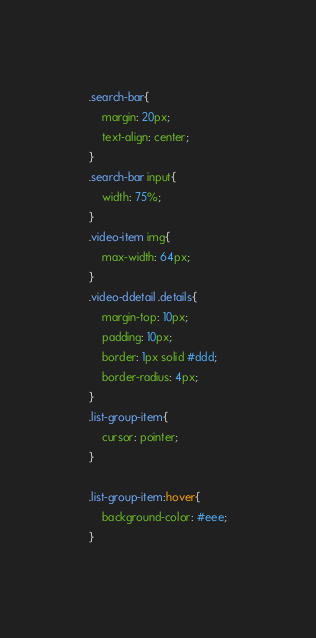<code> <loc_0><loc_0><loc_500><loc_500><_CSS_>.search-bar{
    margin: 20px;
    text-align: center;
}
.search-bar input{
    width: 75%;
}
.video-item img{
    max-width: 64px;
}
.video-ddetail .details{
    margin-top: 10px;
    padding: 10px;
    border: 1px solid #ddd;
    border-radius: 4px;
}
.list-group-item{
    cursor: pointer;
}

.list-group-item:hover{
    background-color: #eee;
}</code> 